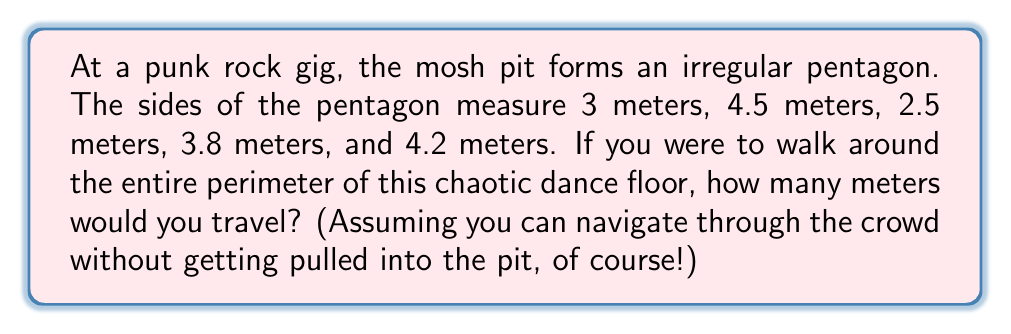Can you solve this math problem? Let's approach this step-by-step:

1) The perimeter of any polygon is the sum of the lengths of all its sides.

2) In this case, we have an irregular pentagon with the following side lengths:
   $a = 3$ m
   $b = 4.5$ m
   $c = 2.5$ m
   $d = 3.8$ m
   $e = 4.2$ m

3) To find the perimeter $P$, we simply add these lengths:

   $$P = a + b + c + d + e$$

4) Substituting the values:

   $$P = 3 + 4.5 + 2.5 + 3.8 + 4.2$$

5) Calculating the sum:

   $$P = 18$$

Therefore, you would travel 18 meters to complete one lap around this irregularly-shaped mosh pit.
Answer: 18 meters 